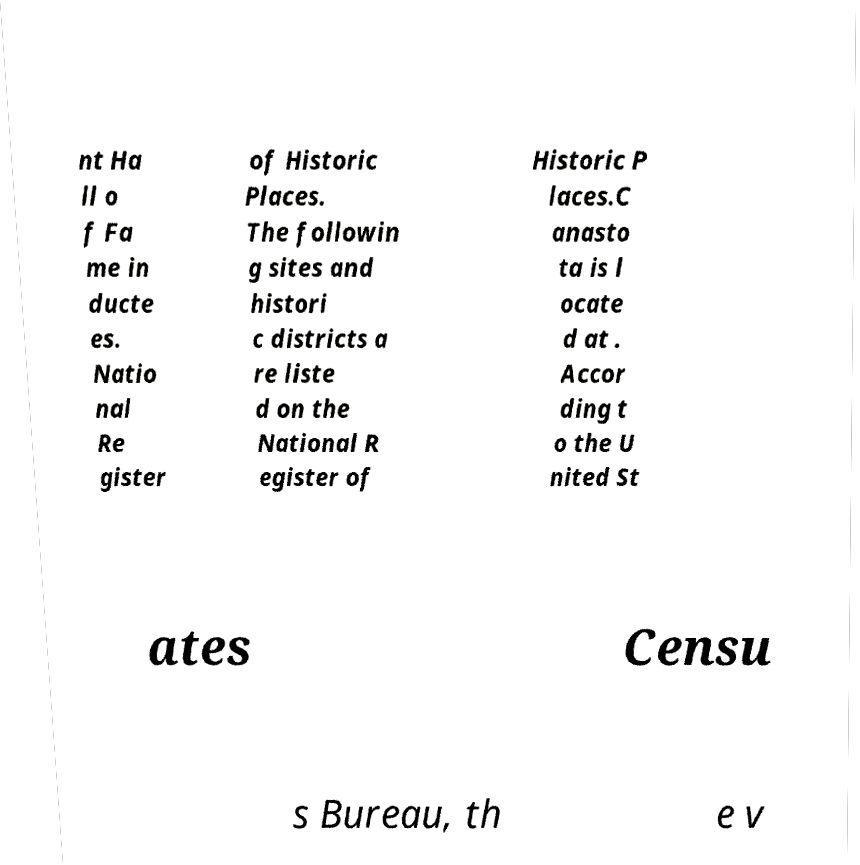For documentation purposes, I need the text within this image transcribed. Could you provide that? nt Ha ll o f Fa me in ducte es. Natio nal Re gister of Historic Places. The followin g sites and histori c districts a re liste d on the National R egister of Historic P laces.C anasto ta is l ocate d at . Accor ding t o the U nited St ates Censu s Bureau, th e v 